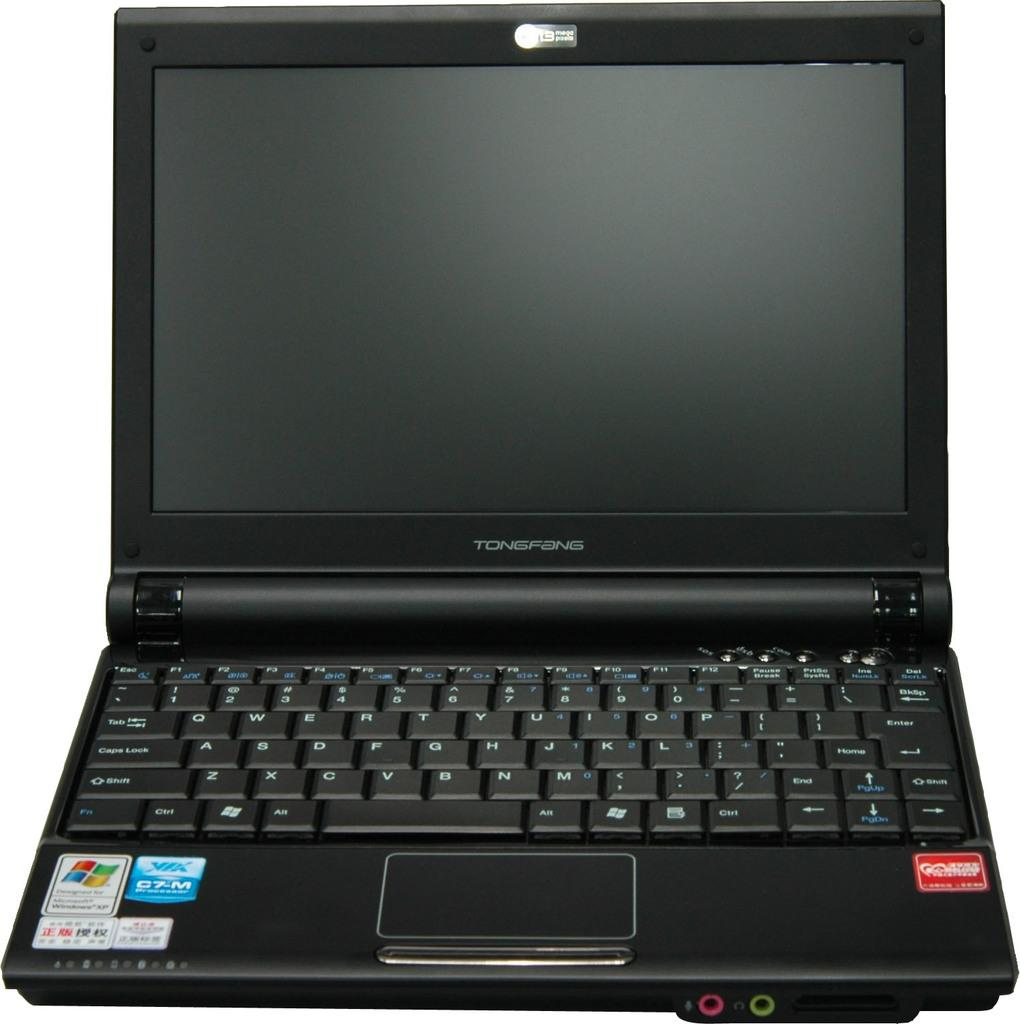<image>
Share a concise interpretation of the image provided. A black TONGFANG laptop, with Microsoft Windows XP. 